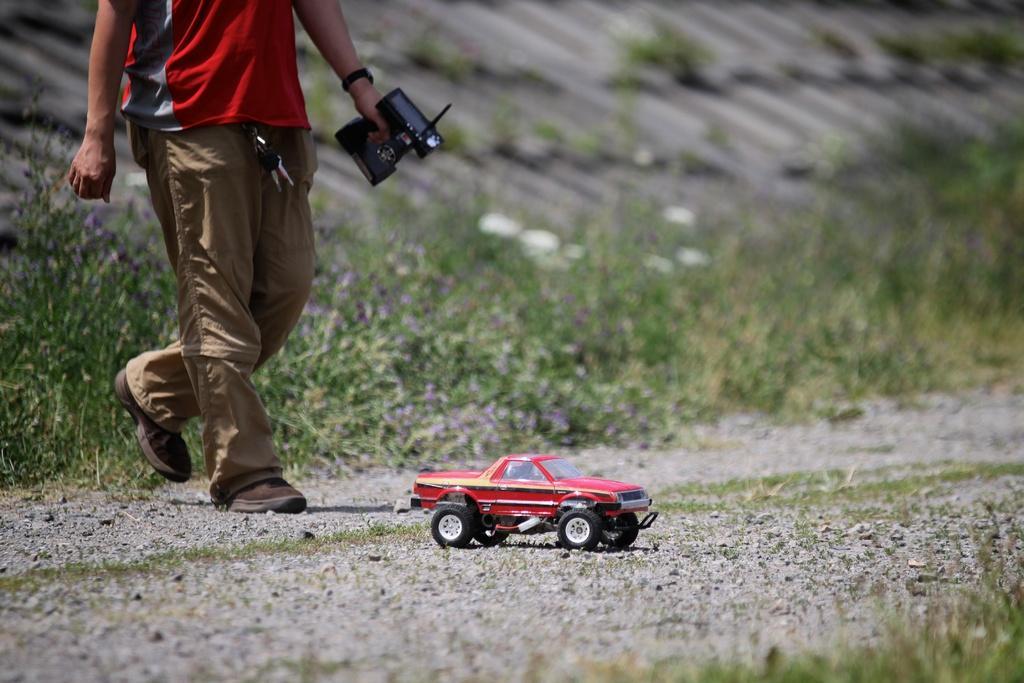In one or two sentences, can you explain what this image depicts? In this image there is one person who is holding some object and walking, and there is a toy car. At the bottom there is walkway and grass, and in the background there are some plants. 